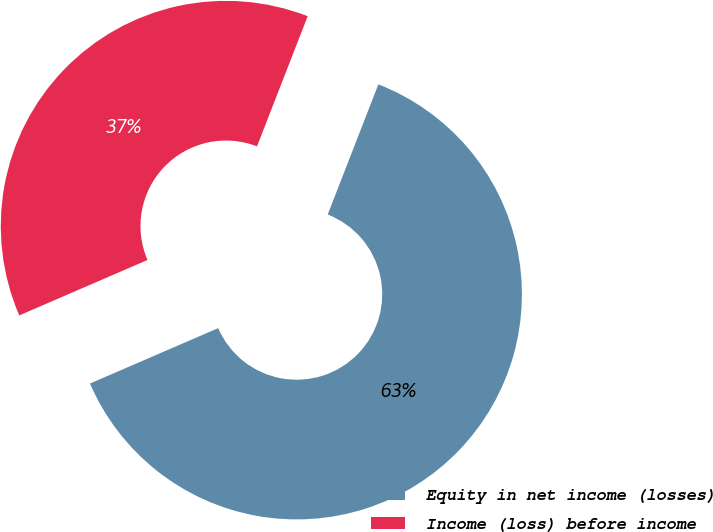Convert chart. <chart><loc_0><loc_0><loc_500><loc_500><pie_chart><fcel>Equity in net income (losses)<fcel>Income (loss) before income<nl><fcel>62.6%<fcel>37.4%<nl></chart> 